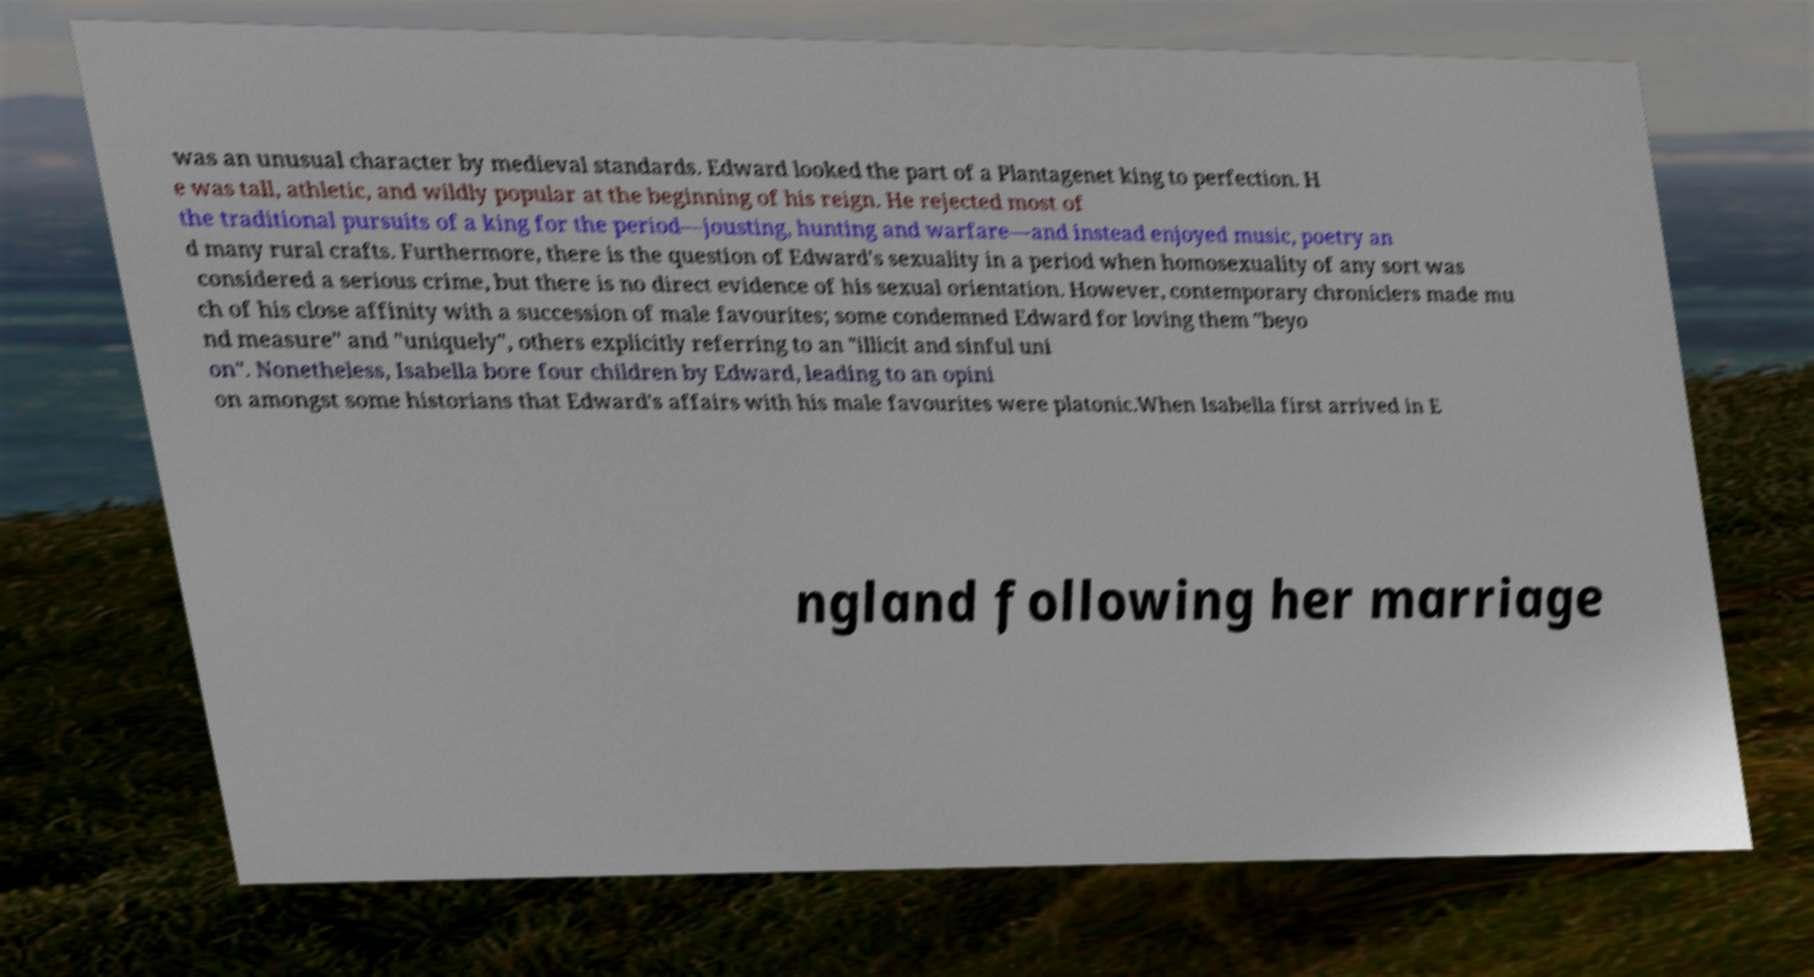Could you assist in decoding the text presented in this image and type it out clearly? was an unusual character by medieval standards. Edward looked the part of a Plantagenet king to perfection. H e was tall, athletic, and wildly popular at the beginning of his reign. He rejected most of the traditional pursuits of a king for the period—jousting, hunting and warfare—and instead enjoyed music, poetry an d many rural crafts. Furthermore, there is the question of Edward's sexuality in a period when homosexuality of any sort was considered a serious crime, but there is no direct evidence of his sexual orientation. However, contemporary chroniclers made mu ch of his close affinity with a succession of male favourites; some condemned Edward for loving them "beyo nd measure" and "uniquely", others explicitly referring to an "illicit and sinful uni on". Nonetheless, Isabella bore four children by Edward, leading to an opini on amongst some historians that Edward's affairs with his male favourites were platonic.When Isabella first arrived in E ngland following her marriage 